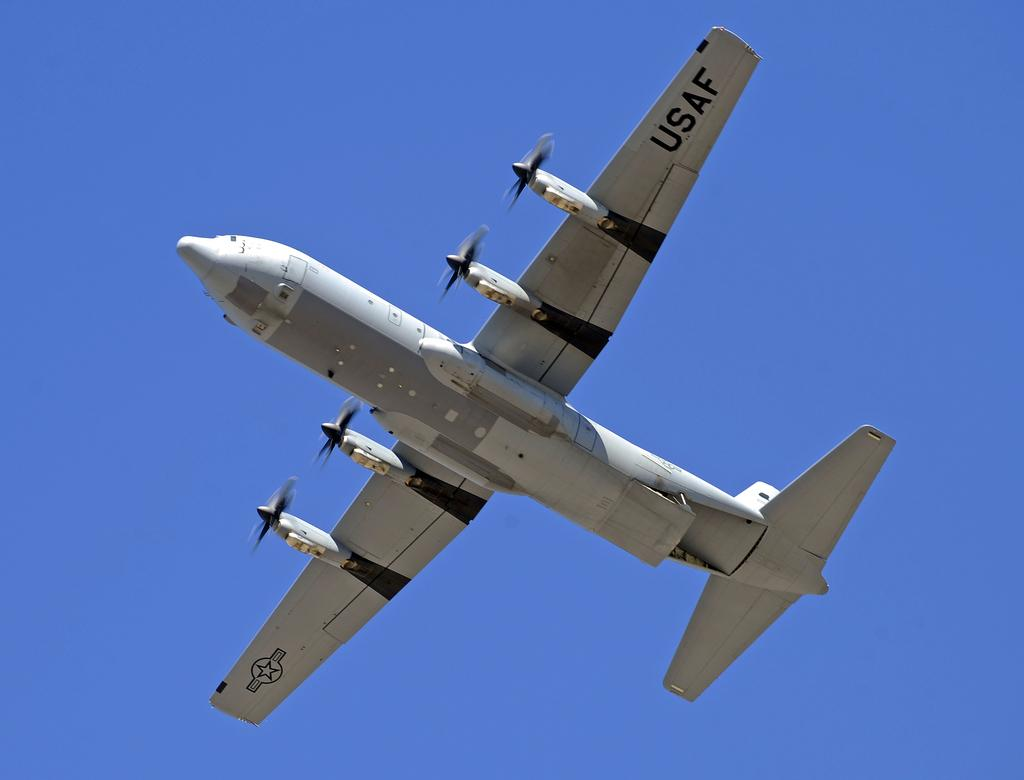<image>
Summarize the visual content of the image. US Airforce airplane with 4 propeller engines are seen from underneath as it flies in the blue sky. 